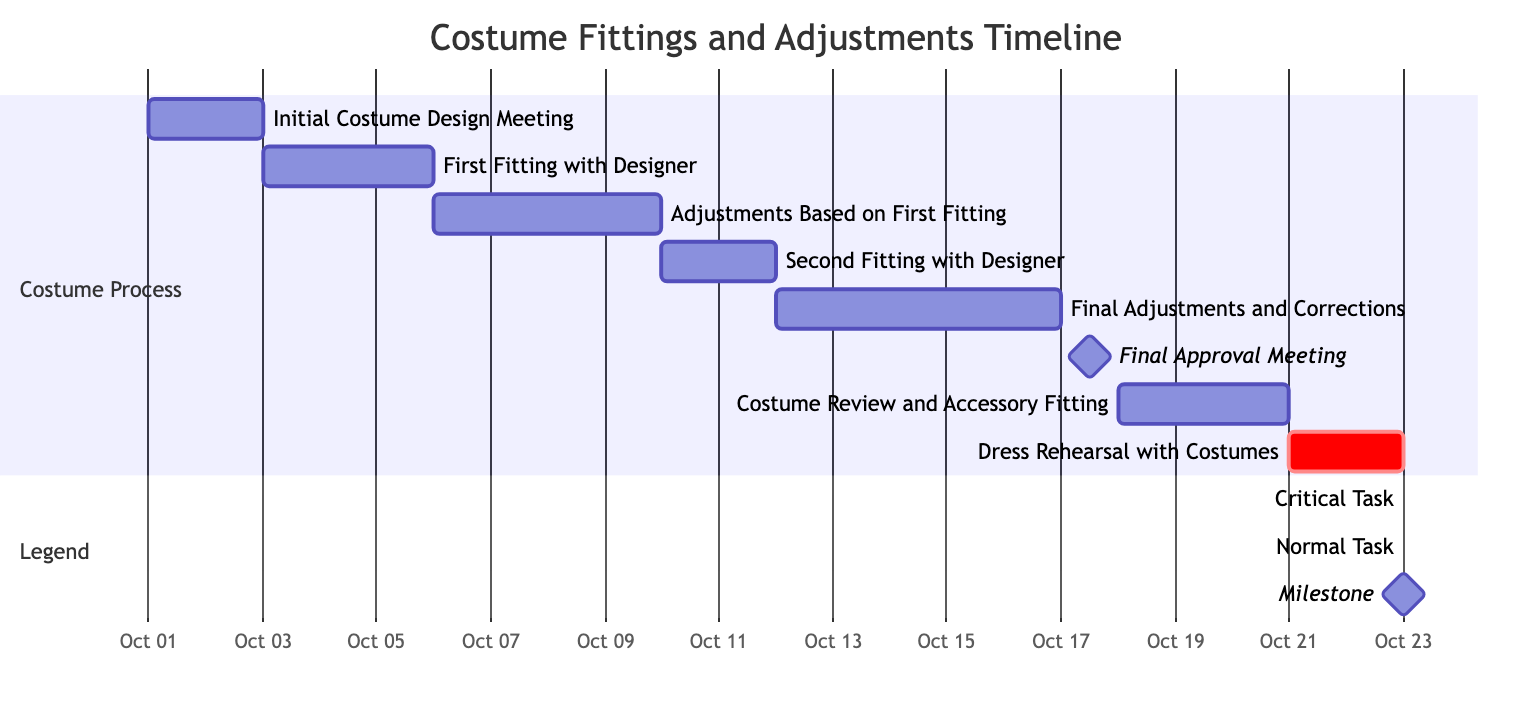What is the duration of the 'Final Adjustments and Corrections'? The 'Final Adjustments and Corrections' task in the diagram is shown with a duration of 5 days, which is directly labeled in the task entry.
Answer: 5 days What task follows the 'Second Fitting with Designer'? The diagram shows that 'Final Adjustments and Corrections' starts immediately after the 'Second Fitting with Designer', indicating its direct succession in the timeline.
Answer: Final Adjustments and Corrections How many tasks are there in total? By counting each task listed in the diagram and provided in the data, there are a total of 8 tasks.
Answer: 8 Which task occurs on October 18th? The diagram specifies that 'Costume Review and Accessory Fitting' is scheduled for October 18th, making it clear from the start date associated with this task.
Answer: Costume Review and Accessory Fitting What is the milestone in this Gantt chart? The milestone is defined as 'Final Approval Meeting', which is marked distinctly in the chart to indicate a critical point that does not have a duration but signifies an important event in the timeline.
Answer: Final Approval Meeting What task has the earliest start date? From the provided data, it is evident that the 'Initial Costume Design Meeting' starts on October 1st, which is earlier than all other tasks in the diagram.
Answer: Initial Costume Design Meeting Which tasks are labeled as critical in the diagram? In the diagram, 'Dress Rehearsal with Costumes' is the only task marked with the 'critical' label, indicating it is a crucial task to the overall schedule and needs special attention.
Answer: Dress Rehearsal with Costumes What is the duration of the 'First Fitting with Designer'? The 'First Fitting with Designer' task is shown in the diagram with a duration of 3 days, as indicated next to the task entry.
Answer: 3 days 